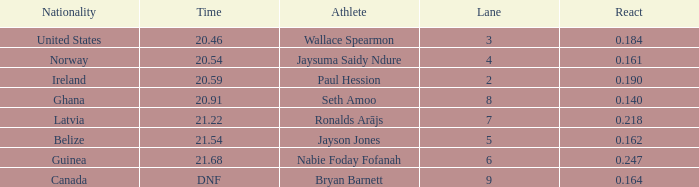What is the lowest lane when react is more than 0.164 and the nationality is guinea? 6.0. 